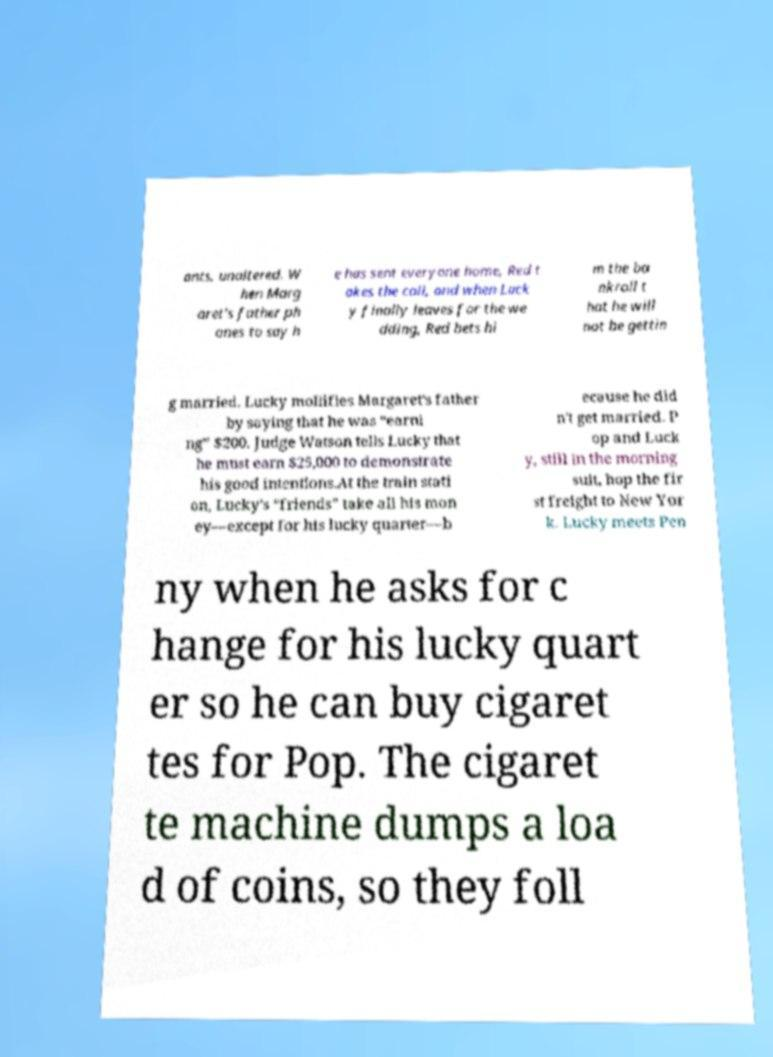There's text embedded in this image that I need extracted. Can you transcribe it verbatim? ants, unaltered. W hen Marg aret's father ph ones to say h e has sent everyone home, Red t akes the call, and when Luck y finally leaves for the we dding, Red bets hi m the ba nkroll t hat he will not be gettin g married. Lucky mollifies Margaret's father by saying that he was “earni ng” $200. Judge Watson tells Lucky that he must earn $25,000 to demonstrate his good intentions.At the train stati on, Lucky's “friends” take all his mon ey—except for his lucky quarter—b ecause he did n't get married. P op and Luck y, still in the morning suit, hop the fir st freight to New Yor k. Lucky meets Pen ny when he asks for c hange for his lucky quart er so he can buy cigaret tes for Pop. The cigaret te machine dumps a loa d of coins, so they foll 